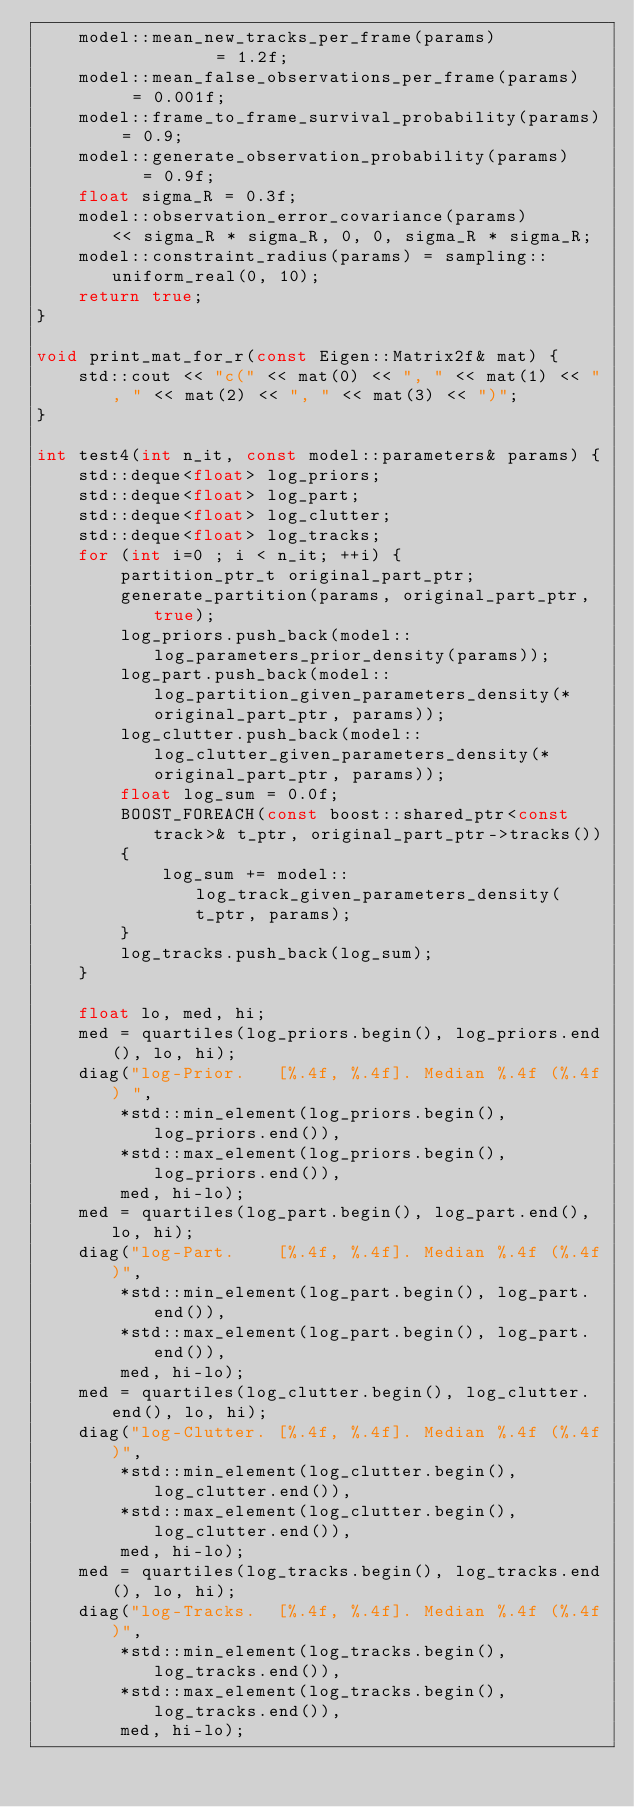Convert code to text. <code><loc_0><loc_0><loc_500><loc_500><_C++_>    model::mean_new_tracks_per_frame(params)           = 1.2f;
    model::mean_false_observations_per_frame(params)   = 0.001f;
    model::frame_to_frame_survival_probability(params) = 0.9;
    model::generate_observation_probability(params)    = 0.9f;
    float sigma_R = 0.3f;
    model::observation_error_covariance(params)       << sigma_R * sigma_R, 0, 0, sigma_R * sigma_R;
    model::constraint_radius(params) = sampling::uniform_real(0, 10);
    return true;
}

void print_mat_for_r(const Eigen::Matrix2f& mat) {
    std::cout << "c(" << mat(0) << ", " << mat(1) << ", " << mat(2) << ", " << mat(3) << ")";
}

int test4(int n_it, const model::parameters& params) {
    std::deque<float> log_priors;
    std::deque<float> log_part;
    std::deque<float> log_clutter;
    std::deque<float> log_tracks;
    for (int i=0 ; i < n_it; ++i) {
        partition_ptr_t original_part_ptr;
        generate_partition(params, original_part_ptr, true);
        log_priors.push_back(model::log_parameters_prior_density(params));
        log_part.push_back(model::log_partition_given_parameters_density(*original_part_ptr, params));
        log_clutter.push_back(model::log_clutter_given_parameters_density(*original_part_ptr, params));
        float log_sum = 0.0f;
        BOOST_FOREACH(const boost::shared_ptr<const track>& t_ptr, original_part_ptr->tracks())
        {
            log_sum += model::log_track_given_parameters_density(t_ptr, params);
        }
        log_tracks.push_back(log_sum);
    }

    float lo, med, hi;
    med = quartiles(log_priors.begin(), log_priors.end(), lo, hi);
    diag("log-Prior.   [%.4f, %.4f]. Median %.4f (%.4f) ",
        *std::min_element(log_priors.begin(), log_priors.end()),
        *std::max_element(log_priors.begin(), log_priors.end()),
        med, hi-lo);
    med = quartiles(log_part.begin(), log_part.end(), lo, hi);
    diag("log-Part.    [%.4f, %.4f]. Median %.4f (%.4f)",
        *std::min_element(log_part.begin(), log_part.end()),
        *std::max_element(log_part.begin(), log_part.end()),
        med, hi-lo);
    med = quartiles(log_clutter.begin(), log_clutter.end(), lo, hi);
    diag("log-Clutter. [%.4f, %.4f]. Median %.4f (%.4f)",
        *std::min_element(log_clutter.begin(), log_clutter.end()),
        *std::max_element(log_clutter.begin(), log_clutter.end()),
        med, hi-lo);
    med = quartiles(log_tracks.begin(), log_tracks.end(), lo, hi);
    diag("log-Tracks.  [%.4f, %.4f]. Median %.4f (%.4f)",
        *std::min_element(log_tracks.begin(), log_tracks.end()),
        *std::max_element(log_tracks.begin(), log_tracks.end()),
        med, hi-lo);

</code> 